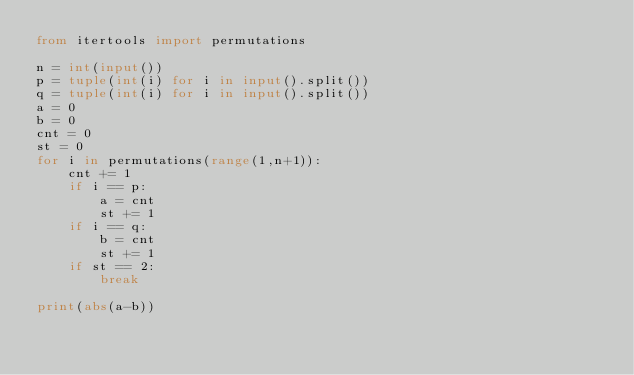Convert code to text. <code><loc_0><loc_0><loc_500><loc_500><_Python_>from itertools import permutations 

n = int(input())
p = tuple(int(i) for i in input().split())
q = tuple(int(i) for i in input().split())
a = 0
b = 0
cnt = 0
st = 0
for i in permutations(range(1,n+1)):
    cnt += 1
    if i == p:
        a = cnt
        st += 1
    if i == q:
        b = cnt
        st += 1
    if st == 2:
        break
    
print(abs(a-b))</code> 